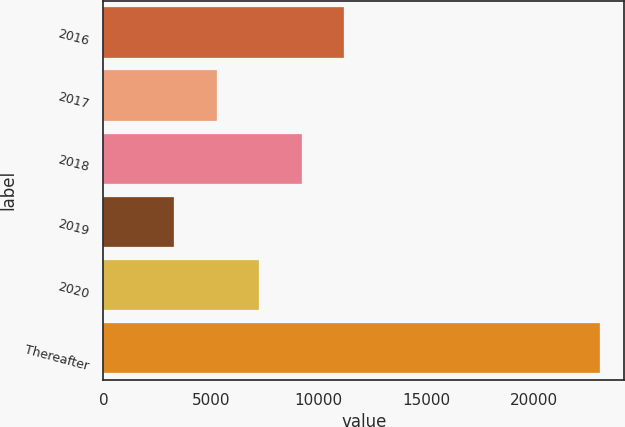Convert chart to OTSL. <chart><loc_0><loc_0><loc_500><loc_500><bar_chart><fcel>2016<fcel>2017<fcel>2018<fcel>2019<fcel>2020<fcel>Thereafter<nl><fcel>11192.4<fcel>5258.1<fcel>9214.3<fcel>3280<fcel>7236.2<fcel>23061<nl></chart> 